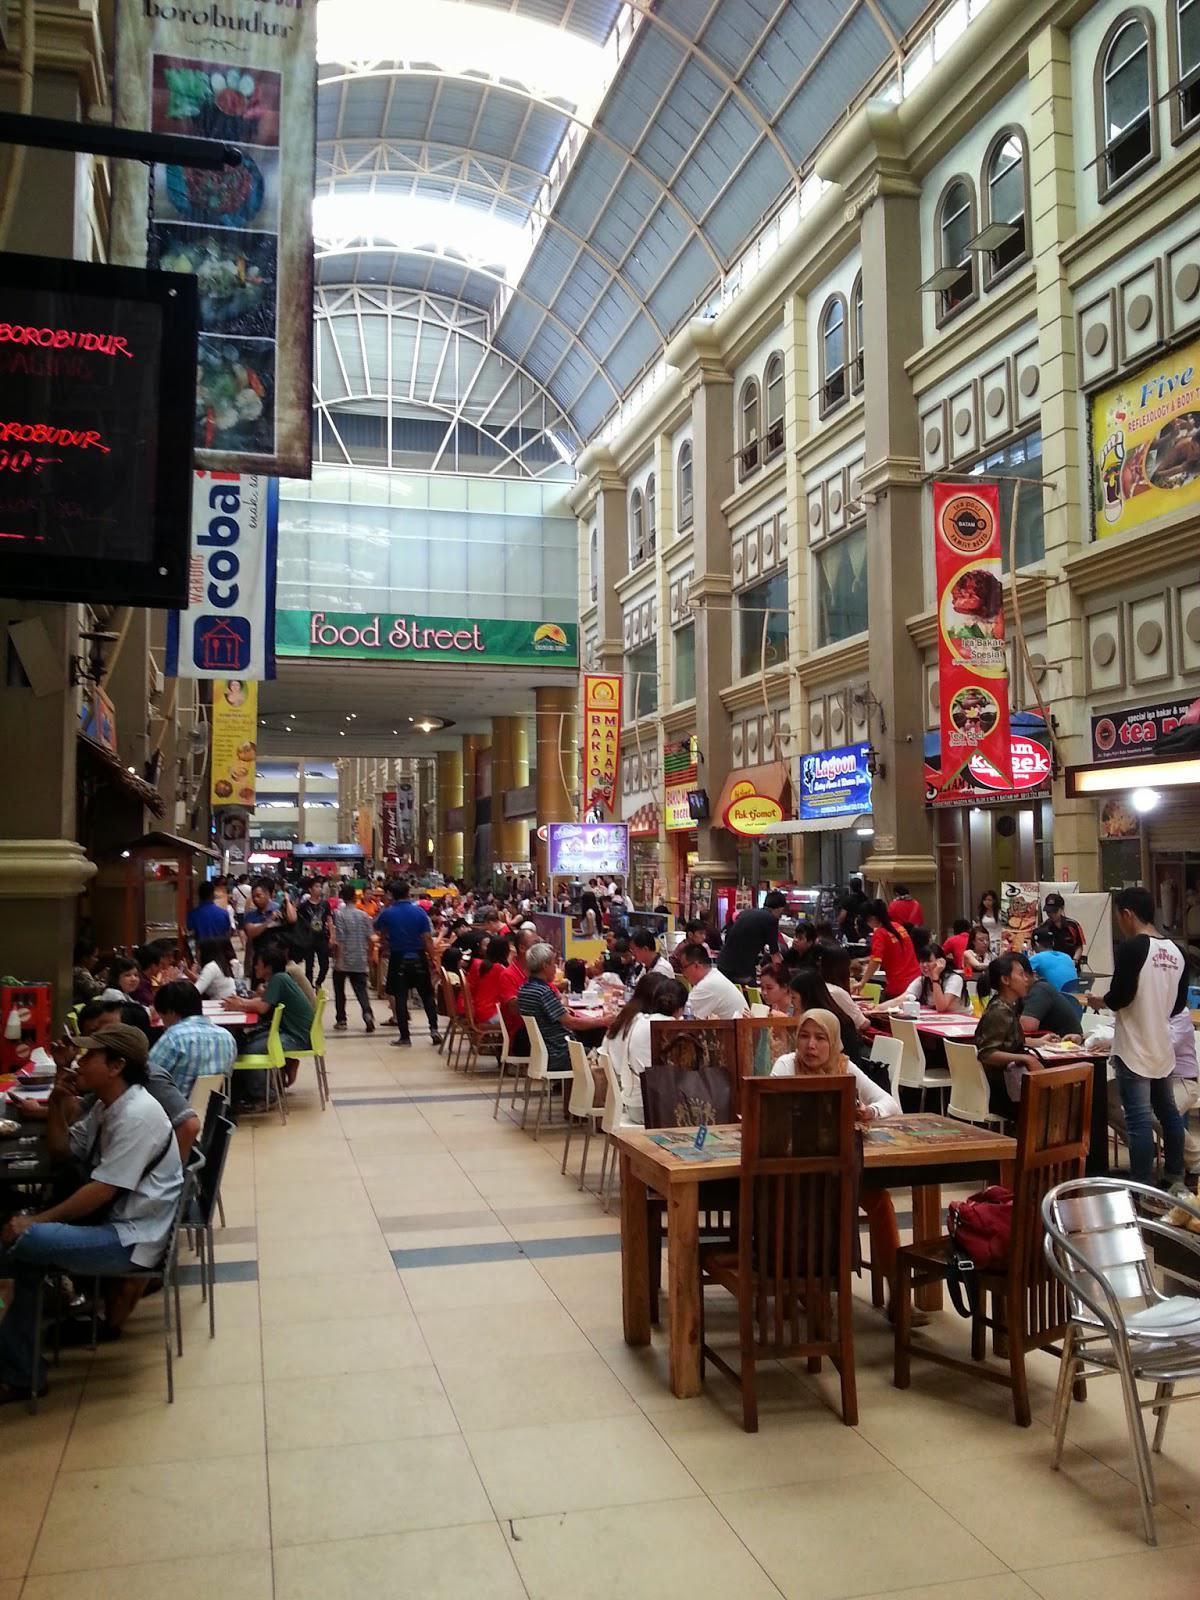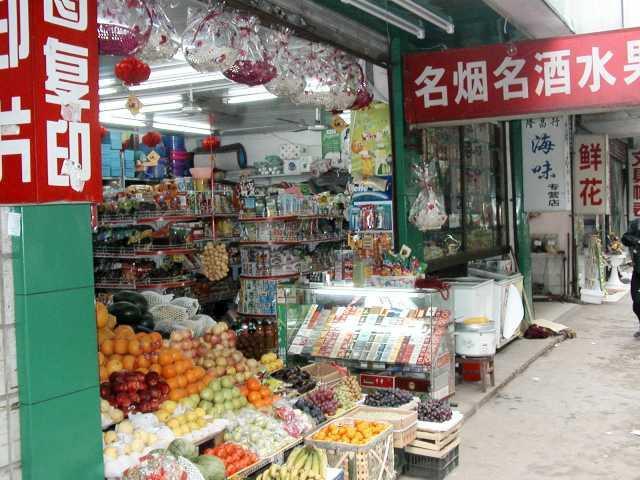The first image is the image on the left, the second image is the image on the right. For the images displayed, is the sentence "One of these shops has a visible coke machine in it." factually correct? Answer yes or no. No. The first image is the image on the left, the second image is the image on the right. Assess this claim about the two images: "An image shows crowds on a street with a sign depicting a walking man on the left and a row of cylindrical lights under an overhanding roof on the right.". Correct or not? Answer yes or no. No. 